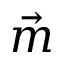Convert formula to latex. <formula><loc_0><loc_0><loc_500><loc_500>\vec { m }</formula> 